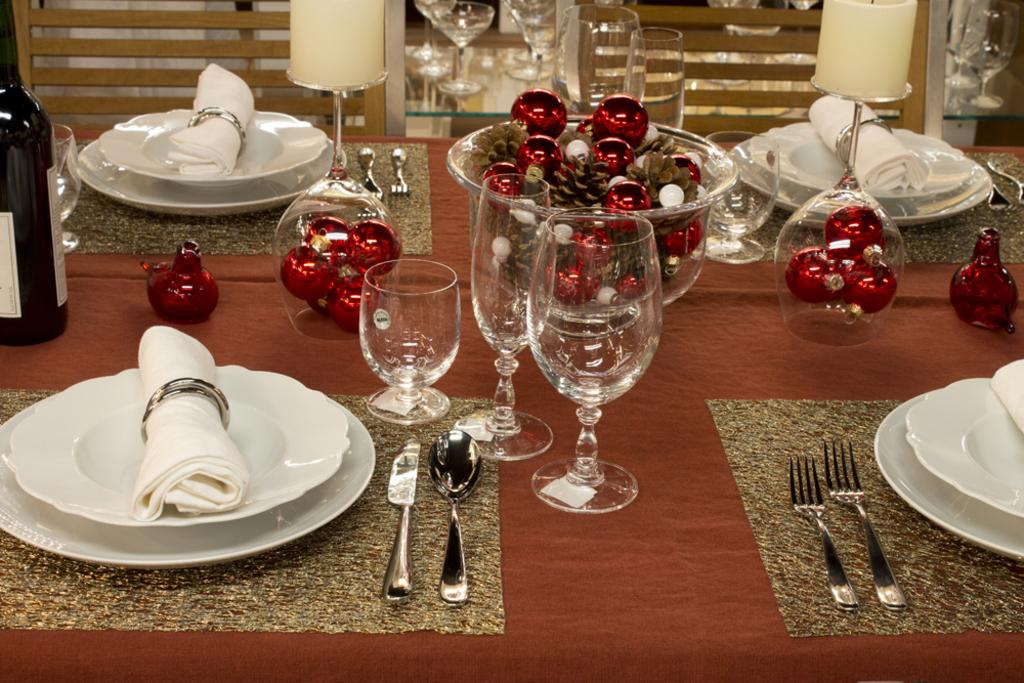What type of furniture is present in the image? There is a table in the image. What objects are placed on the table? There are plates, glasses, a bowl, and a bottle on the table. What type of prose can be seen on the plates in the image? There is no prose visible on the plates in the image. What color is the oven in the image? There is no oven present in the image. 